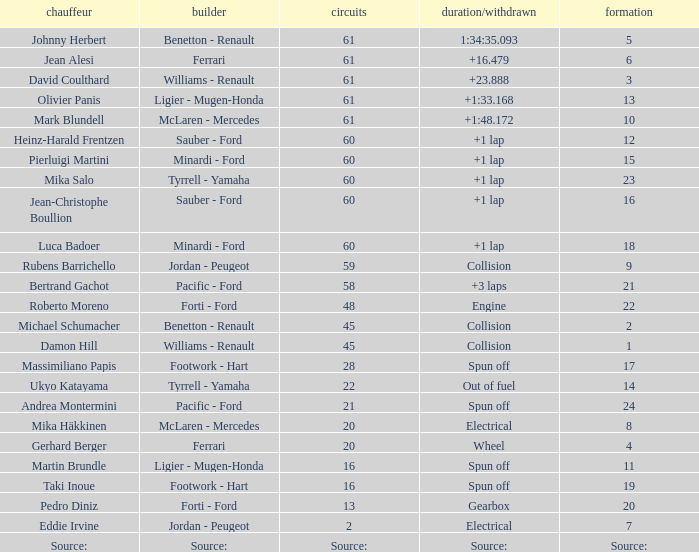What's the time/retired for constructor source:? Source:. 